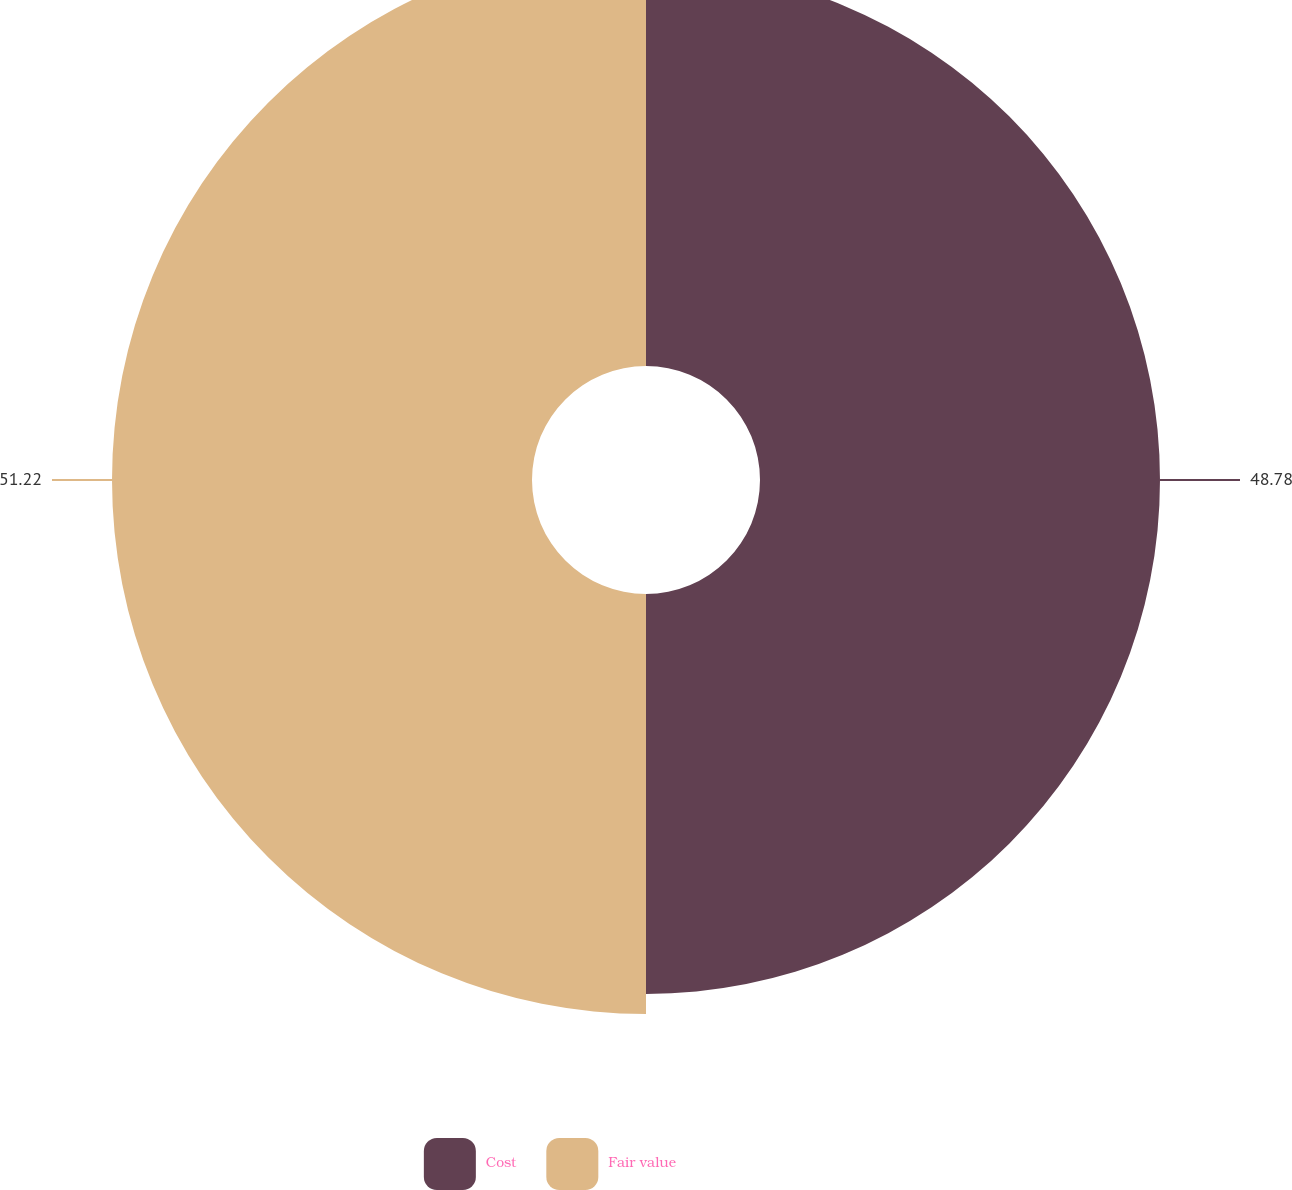Convert chart to OTSL. <chart><loc_0><loc_0><loc_500><loc_500><pie_chart><fcel>Cost<fcel>Fair value<nl><fcel>48.78%<fcel>51.22%<nl></chart> 